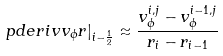Convert formula to latex. <formula><loc_0><loc_0><loc_500><loc_500>\left . \ p d e r i v { v _ { \phi } } { r } \right | _ { i - \frac { 1 } { 2 } } \approx \frac { v _ { \phi } ^ { i , j } - v _ { \phi } ^ { i - 1 , j } } { r _ { i } - r _ { i - 1 } }</formula> 